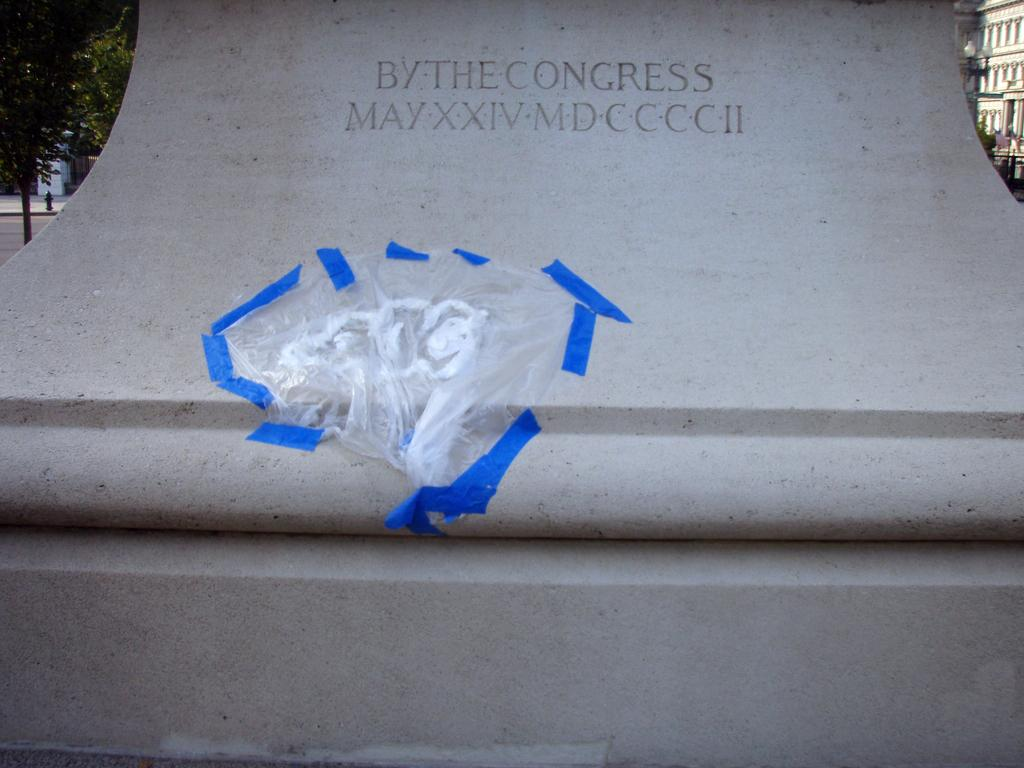What can be seen on the wall in the image? There is writing on the wall in the image. What type of vegetation is on the left side of the image? There is a tree on the left side of the image. What type of structure is on the right side of the image? There is a building on the right side of the image. What is another object on the right side of the image? There is a light pole on the right side of the image. How many frogs are sitting on the light pole in the image? There are no frogs present in the image; the light pole is the only object mentioned on the right side of the image. Can you see any fish swimming in the tree on the left side of the image? There are no fish present in the image; the tree is the only object mentioned on the left side of the image. 